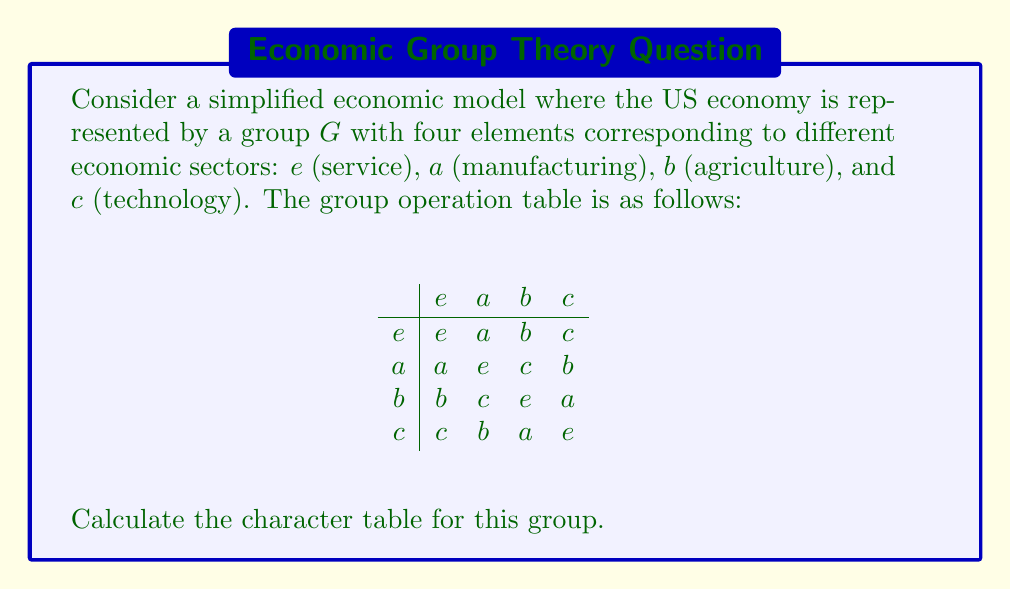Could you help me with this problem? To calculate the character table for this group, we'll follow these steps:

1) First, identify the conjugacy classes:
   - $\{e\}$ (identity)
   - $\{a\}$
   - $\{b, c\}$

2) The number of irreducible representations equals the number of conjugacy classes, so we have 3 irreducible representations.

3) Let's call these representations $\chi_1$, $\chi_2$, and $\chi_3$.

4) $\chi_1$ is always the trivial representation, with all characters equal to 1.

5) For a group of order 4, the possible dimensions of irreducible representations are 1 and 2. We know we need three representations, so we must have two 1-dimensional representations and one 2-dimensional representation.

6) Let $\chi_2$ be the other 1-dimensional representation. Since $a^2 = e$, $\chi_2(a)$ must be $\pm 1$. Choose $\chi_2(a) = -1$.

7) For $\chi_2(b)$ and $\chi_2(c)$, we know $b^2 = c^2 = e$, so these must also be $\pm 1$. Since $b$ and $c$ are in the same conjugacy class, $\chi_2(b) = \chi_2(c)$. Choose $\chi_2(b) = \chi_2(c) = -1$.

8) For $\chi_3$, which is 2-dimensional:
   - $\chi_3(e) = 2$ (trace of 2x2 identity matrix)
   - $\chi_3(a) = 0$ (trace of a matrix representing a 180° rotation)
   - $\chi_3(b) = \chi_3(c) = 0$ (trace of matrices representing 120° rotations)

9) Verify orthogonality relations to confirm the table is correct.

The resulting character table is:

$$
\begin{array}{c|ccc}
    & \{e\} & \{a\} & \{b,c\} \\
\hline
\chi_1 & 1 & 1 & 1 \\
\chi_2 & 1 & -1 & -1 \\
\chi_3 & 2 & 0 & 0
\end{array}
$$
Answer: $$
\begin{array}{c|ccc}
    & \{e\} & \{a\} & \{b,c\} \\
\hline
\chi_1 & 1 & 1 & 1 \\
\chi_2 & 1 & -1 & -1 \\
\chi_3 & 2 & 0 & 0
\end{array}
$$ 